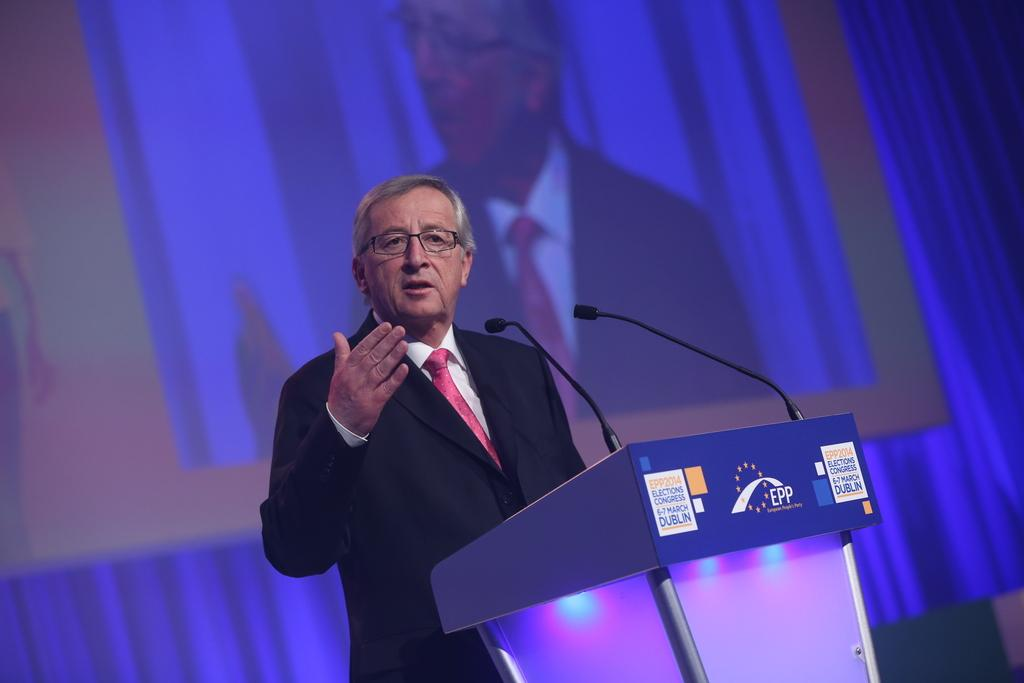What is the man in the image doing? The man is standing behind a podium. What is on the podium that the man is standing behind? There are microphones on the podium. What is visible behind the man? There is a screen behind the man. What is the color of the curtain behind the screen? There is a blue curtain behind the screen. What is the man's desire for the rail in the image? There is no rail present in the image, so it is not possible to determine the man's desire for a rail. 